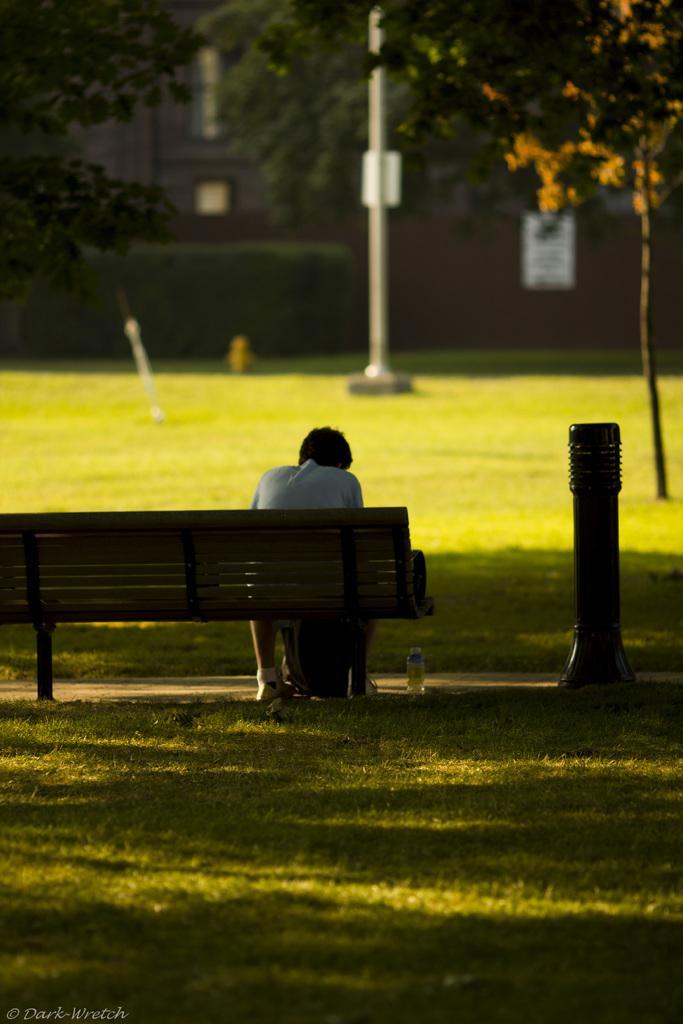Can you describe this image briefly? In the center of the image there is a person sitting on the bench. At the bottom of the image we can see grass, water bottle. On the right side of the image we can see tree and pole. In the background we can see grass, pole, trees and building. 